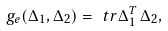Convert formula to latex. <formula><loc_0><loc_0><loc_500><loc_500>g _ { e } ( \Delta _ { 1 } , \Delta _ { 2 } ) = \ t r \Delta _ { 1 } ^ { T } \, \Delta _ { 2 } ,</formula> 